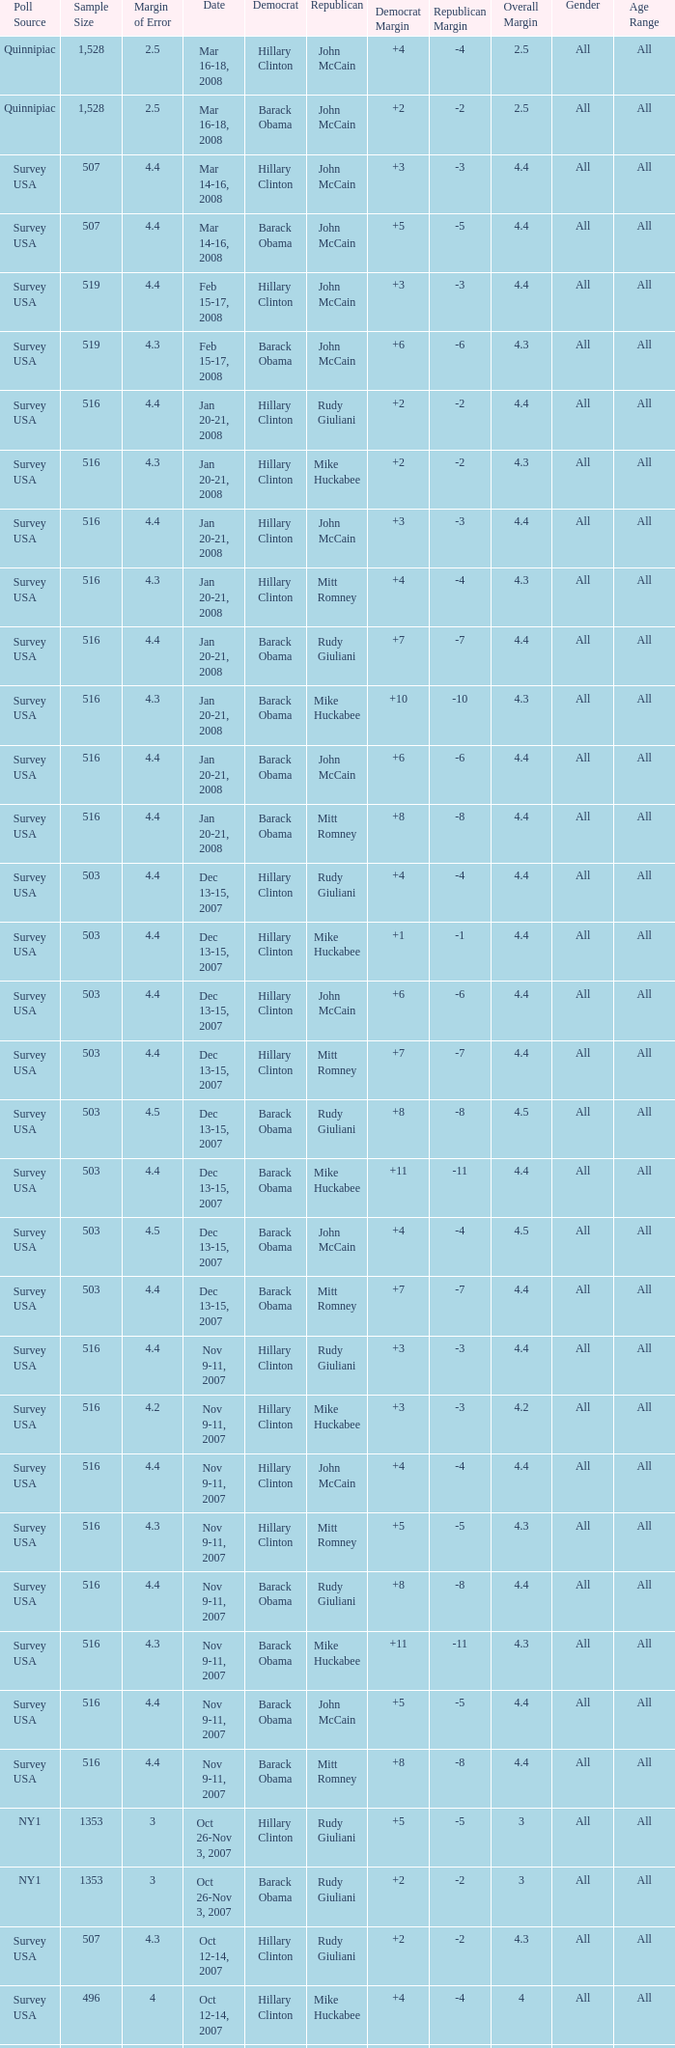What is the sample size of the poll taken on Dec 13-15, 2007 that had a margin of error of more than 4 and resulted with Republican Mike Huckabee? 503.0. 